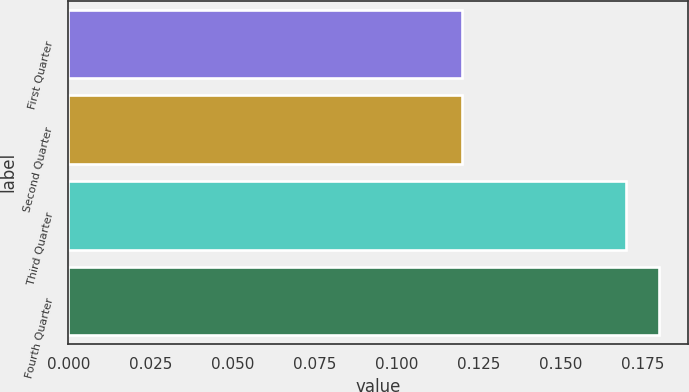<chart> <loc_0><loc_0><loc_500><loc_500><bar_chart><fcel>First Quarter<fcel>Second Quarter<fcel>Third Quarter<fcel>Fourth Quarter<nl><fcel>0.12<fcel>0.12<fcel>0.17<fcel>0.18<nl></chart> 